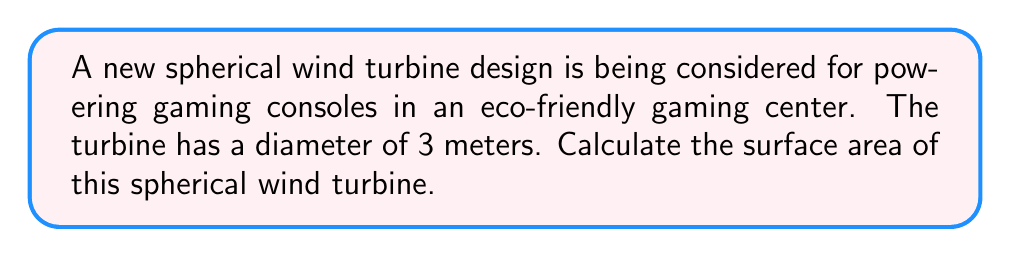Provide a solution to this math problem. To solve this problem, we need to use the formula for the surface area of a sphere:

$$A = 4\pi r^2$$

Where:
$A$ = surface area
$r$ = radius of the sphere

Given:
- The diameter of the spherical wind turbine is 3 meters.

Step 1: Calculate the radius
The radius is half the diameter:
$$r = \frac{diameter}{2} = \frac{3}{2} = 1.5\text{ meters}$$

Step 2: Substitute the radius into the surface area formula
$$A = 4\pi (1.5)^2$$

Step 3: Simplify and calculate
$$A = 4\pi (2.25)$$
$$A = 9\pi$$
$$A \approx 28.27\text{ square meters}$$

[asy]
import geometry;

size(200);
draw(circle((0,0),1.5), rgb(0,0.5,0));
draw((0,0)--(1.5,0), arrow=Arrow(TeXHead));
label("1.5 m", (0.75,-0.2), S);
label("3 m", (-1.5,-1.7), S);
draw((-1.5,-1.5)--(1.5,-1.5), arrow=Arrows(TeXHead));
[/asy]
Answer: The surface area of the spherical wind turbine is $9\pi \approx 28.27\text{ m}^2$. 